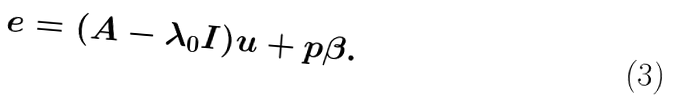<formula> <loc_0><loc_0><loc_500><loc_500>e = ( A - \lambda _ { 0 } I ) u + p \beta .</formula> 